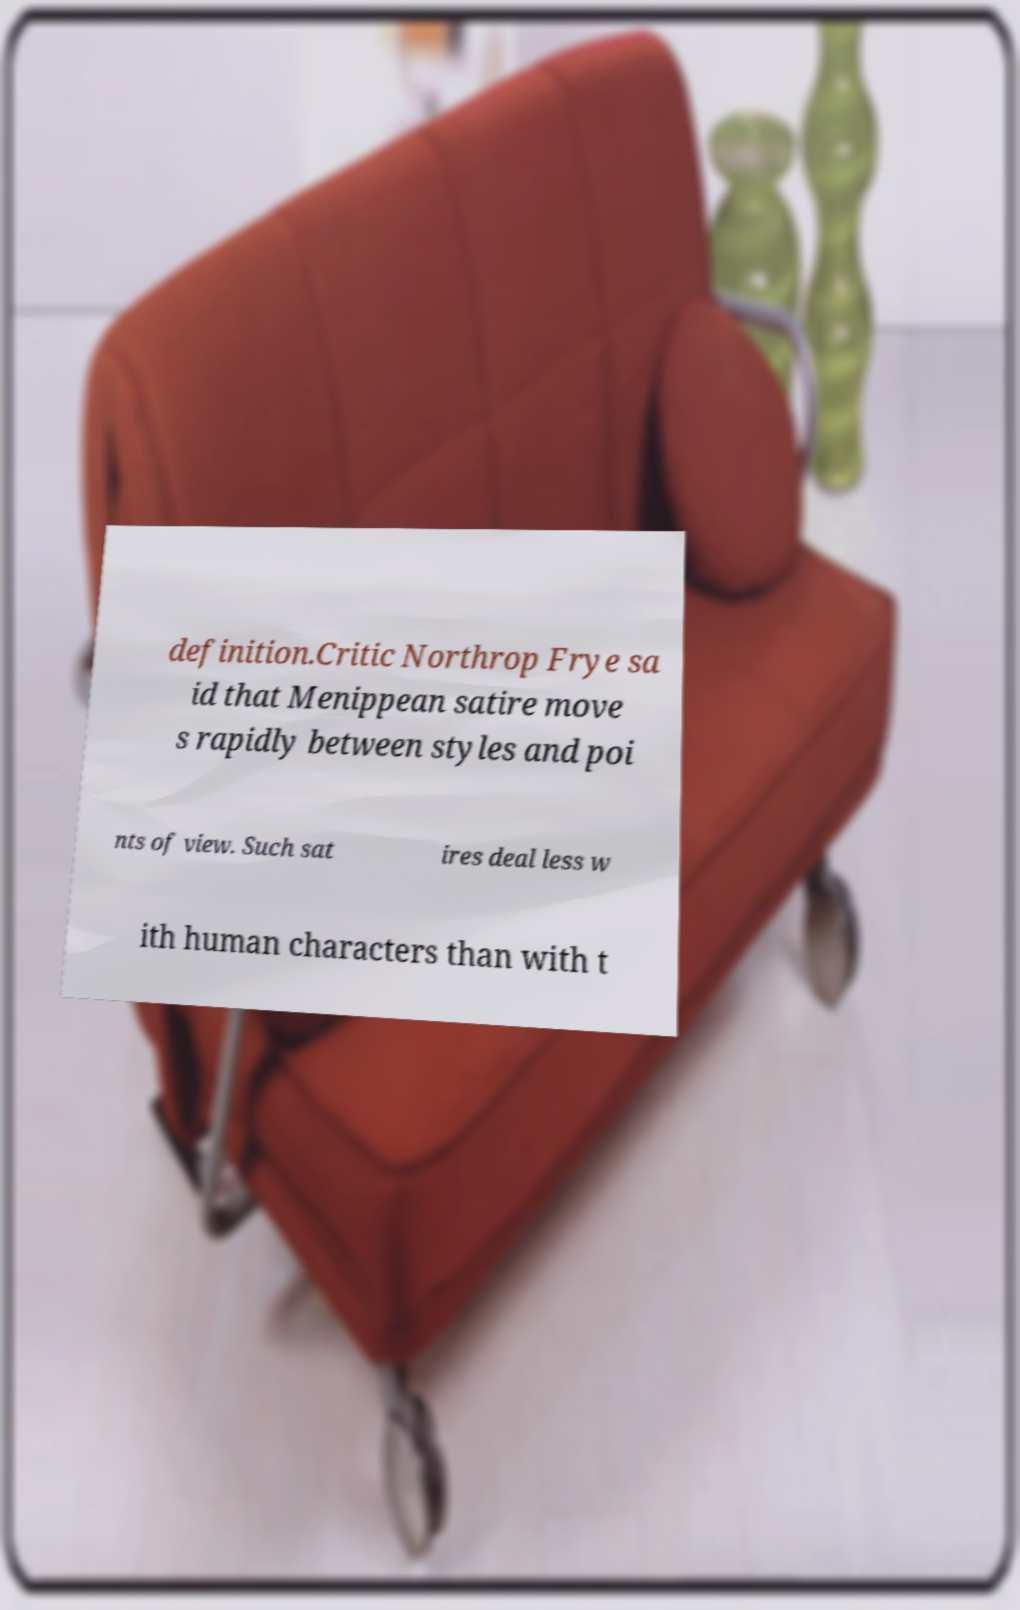Could you extract and type out the text from this image? definition.Critic Northrop Frye sa id that Menippean satire move s rapidly between styles and poi nts of view. Such sat ires deal less w ith human characters than with t 